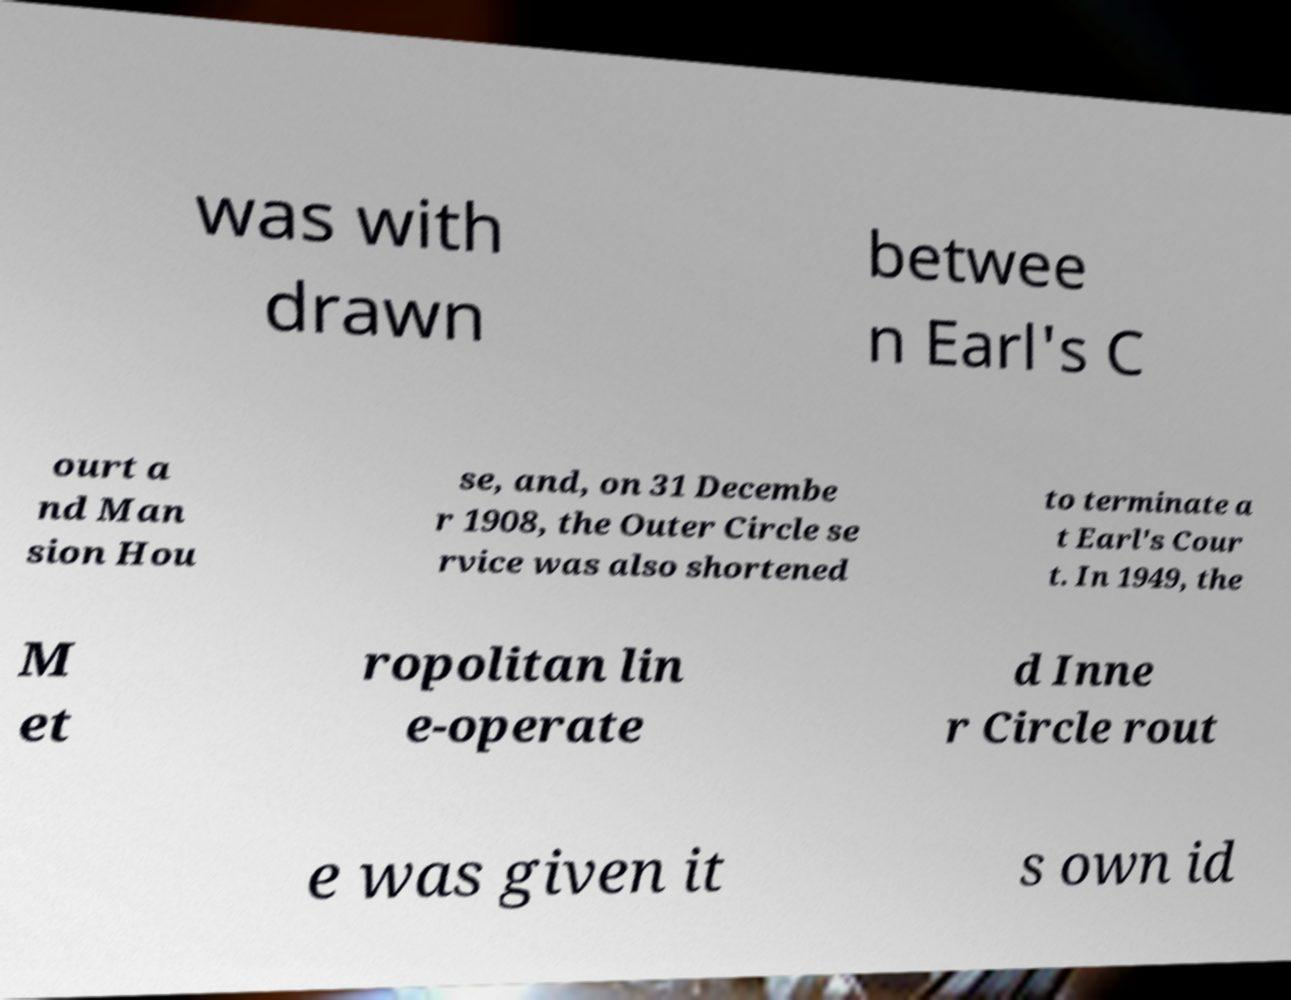Could you assist in decoding the text presented in this image and type it out clearly? was with drawn betwee n Earl's C ourt a nd Man sion Hou se, and, on 31 Decembe r 1908, the Outer Circle se rvice was also shortened to terminate a t Earl's Cour t. In 1949, the M et ropolitan lin e-operate d Inne r Circle rout e was given it s own id 